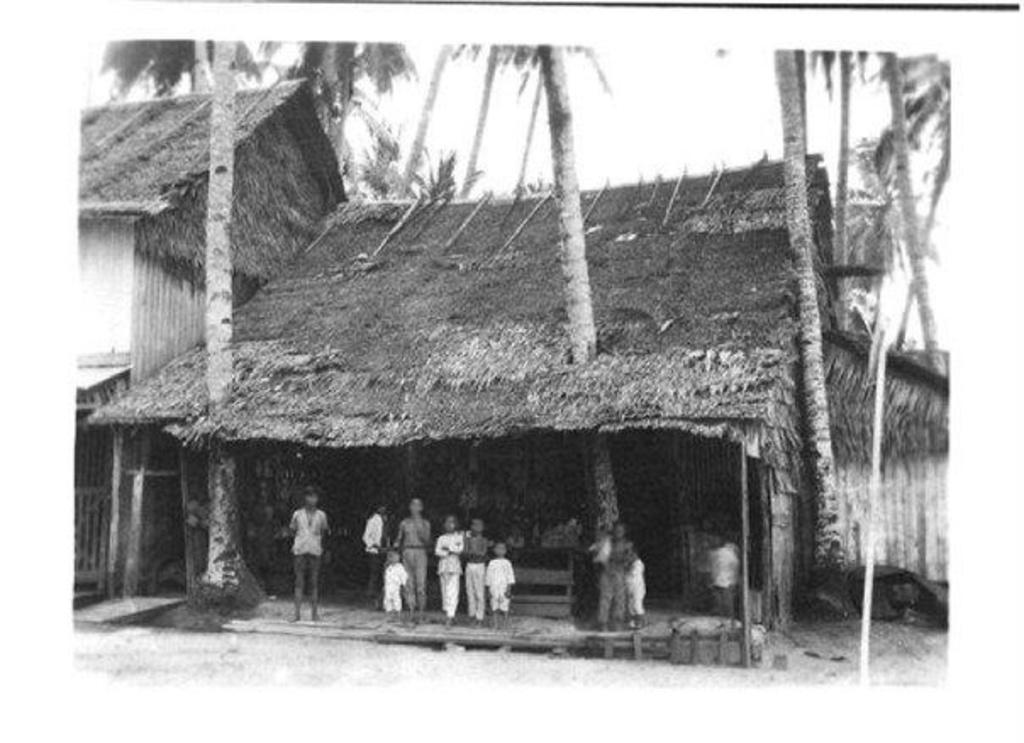What is the color scheme of the image? The image is black and white. What type of structures can be seen in the image? There are houses in the image. Who or what is present in the image besides the houses? There are children standing in the image. What type of vegetation is visible in the image? There are trees in the image. Can you tell me how many deer are visible in the image? There are no deer present in the image; it features houses, children, and trees. What type of animal can be seen interacting with the children in the image? There is no animal shown interacting with the children in the image; only the houses, children, and trees are present. 